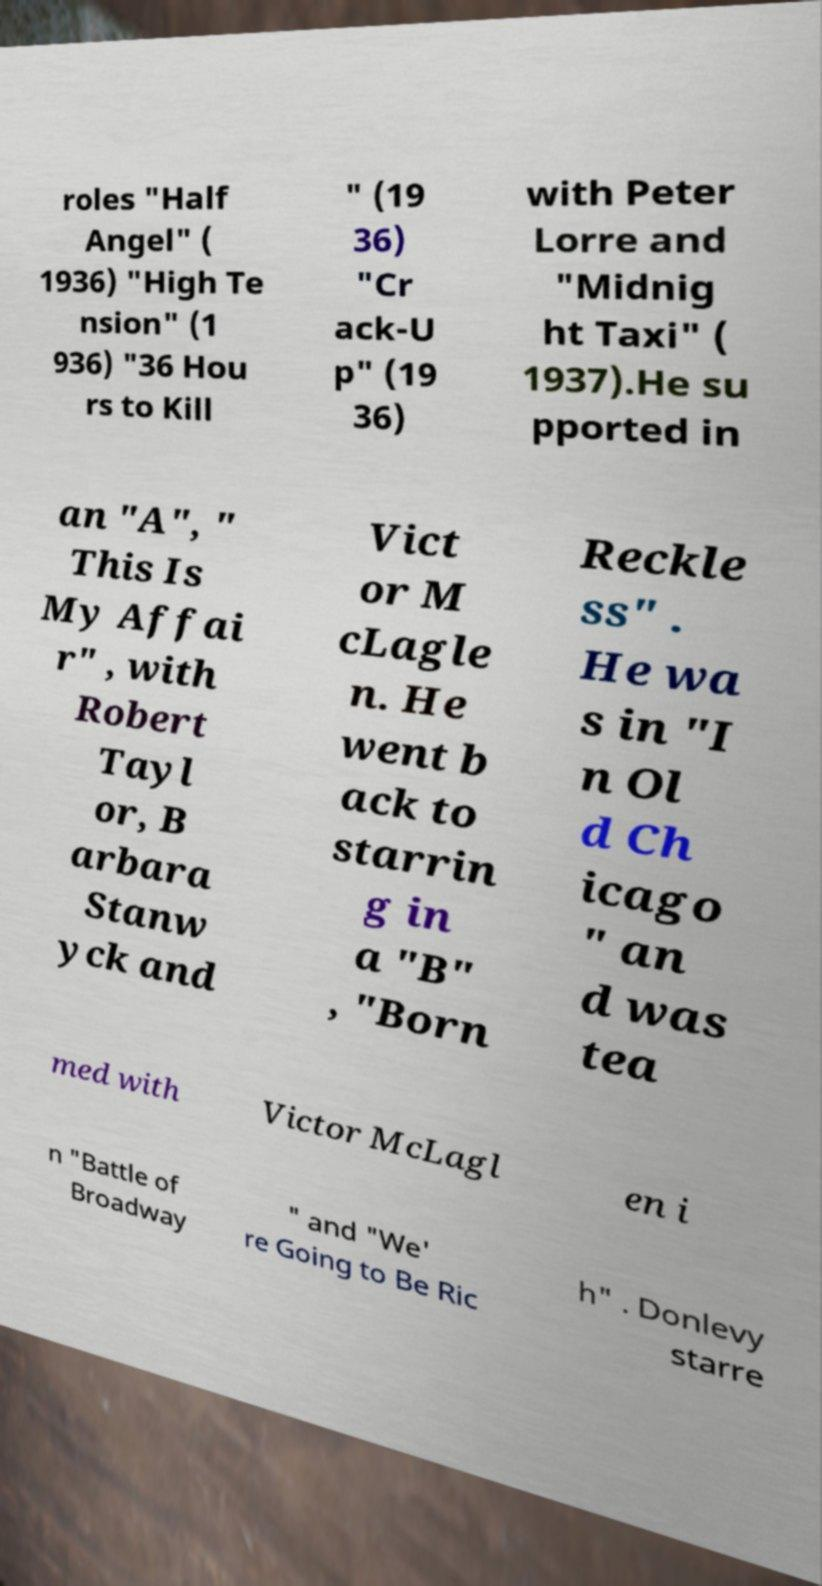Can you accurately transcribe the text from the provided image for me? roles "Half Angel" ( 1936) "High Te nsion" (1 936) "36 Hou rs to Kill " (19 36) "Cr ack-U p" (19 36) with Peter Lorre and "Midnig ht Taxi" ( 1937).He su pported in an "A", " This Is My Affai r" , with Robert Tayl or, B arbara Stanw yck and Vict or M cLagle n. He went b ack to starrin g in a "B" , "Born Reckle ss" . He wa s in "I n Ol d Ch icago " an d was tea med with Victor McLagl en i n "Battle of Broadway " and "We' re Going to Be Ric h" . Donlevy starre 